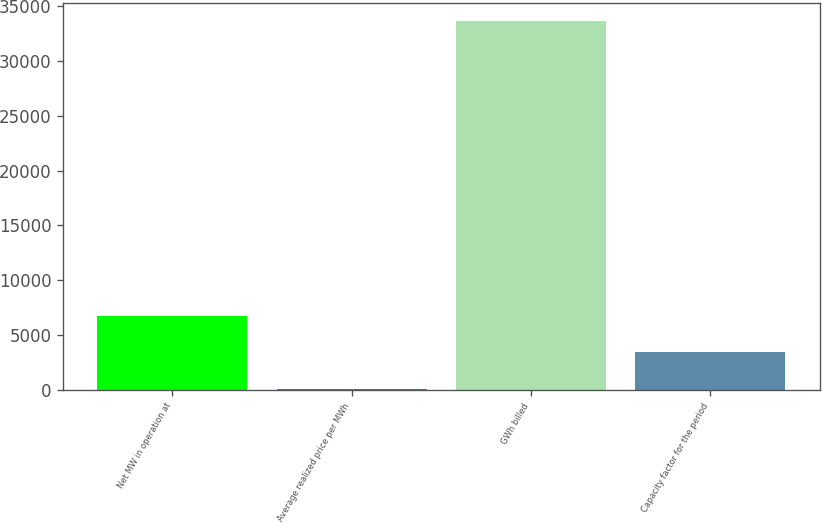Convert chart. <chart><loc_0><loc_0><loc_500><loc_500><bar_chart><fcel>Net MW in operation at<fcel>Average realized price per MWh<fcel>GWh billed<fcel>Capacity factor for the period<nl><fcel>6762<fcel>42.26<fcel>33641<fcel>3402.13<nl></chart> 